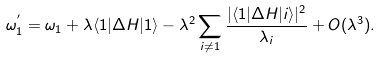Convert formula to latex. <formula><loc_0><loc_0><loc_500><loc_500>\omega _ { 1 } ^ { ^ { \prime } } = \omega _ { 1 } + \lambda \langle 1 | \Delta H | 1 \rangle - \lambda ^ { 2 } \sum _ { i \neq 1 } \frac { | \langle 1 | \Delta H | i \rangle | ^ { 2 } } { \lambda _ { i } } + O ( \lambda ^ { 3 } ) .</formula> 